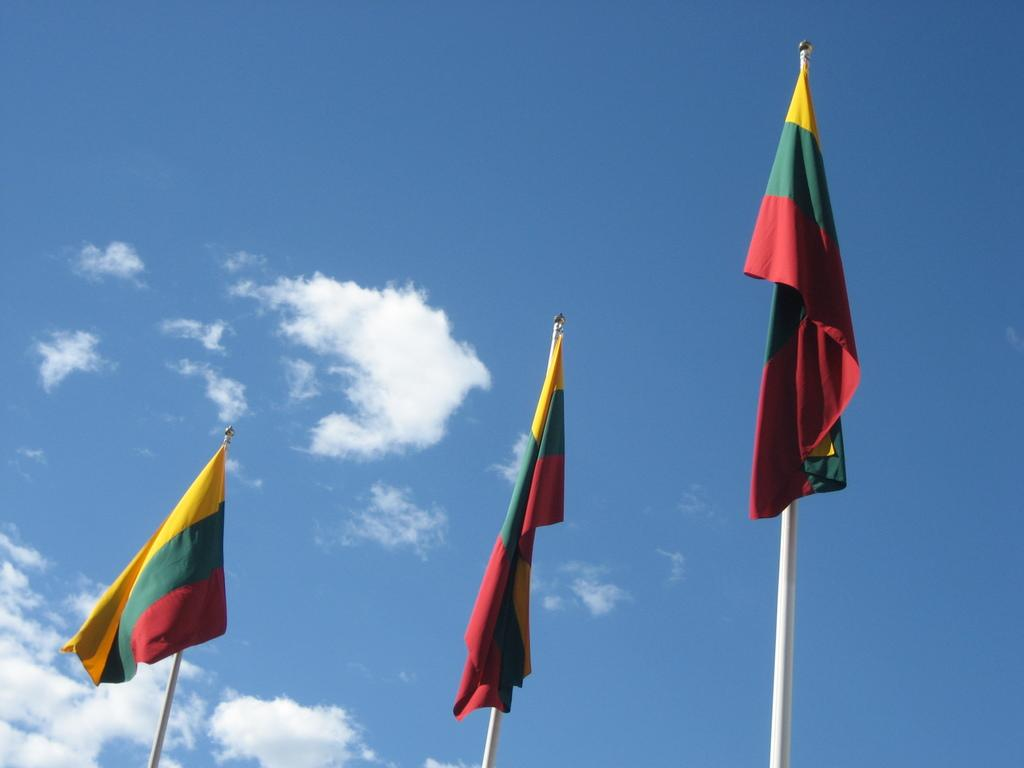Where is the first flag located in the image? The first flag is on the left side of the image, attached to a pole. How many flags are on the right side of the image? There are two flags on the right side of the image, each attached to a separate pole. What can be seen in the background of the image? There are clouds visible in the blue sky in the background of the image. What type of fan is being offered to the person in the image? There is no fan present in the image, nor is there any indication of an offer being made. 